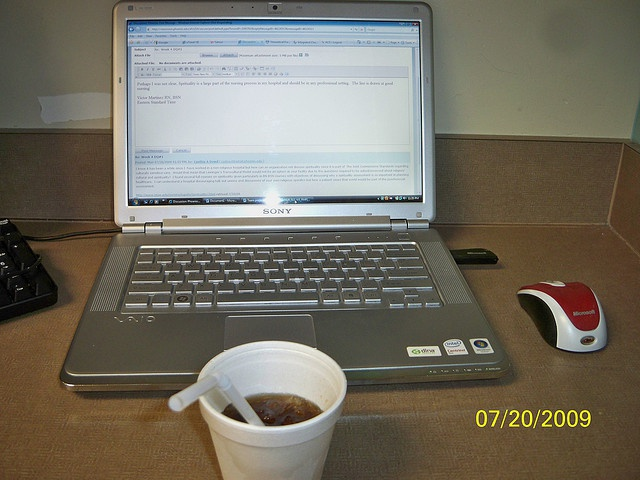Describe the objects in this image and their specific colors. I can see laptop in black, lightgray, gray, and darkgray tones, keyboard in black, gray, and darkgray tones, cup in black, darkgray, lightgray, and gray tones, mouse in black, maroon, and darkgray tones, and keyboard in black, gray, and darkgray tones in this image. 